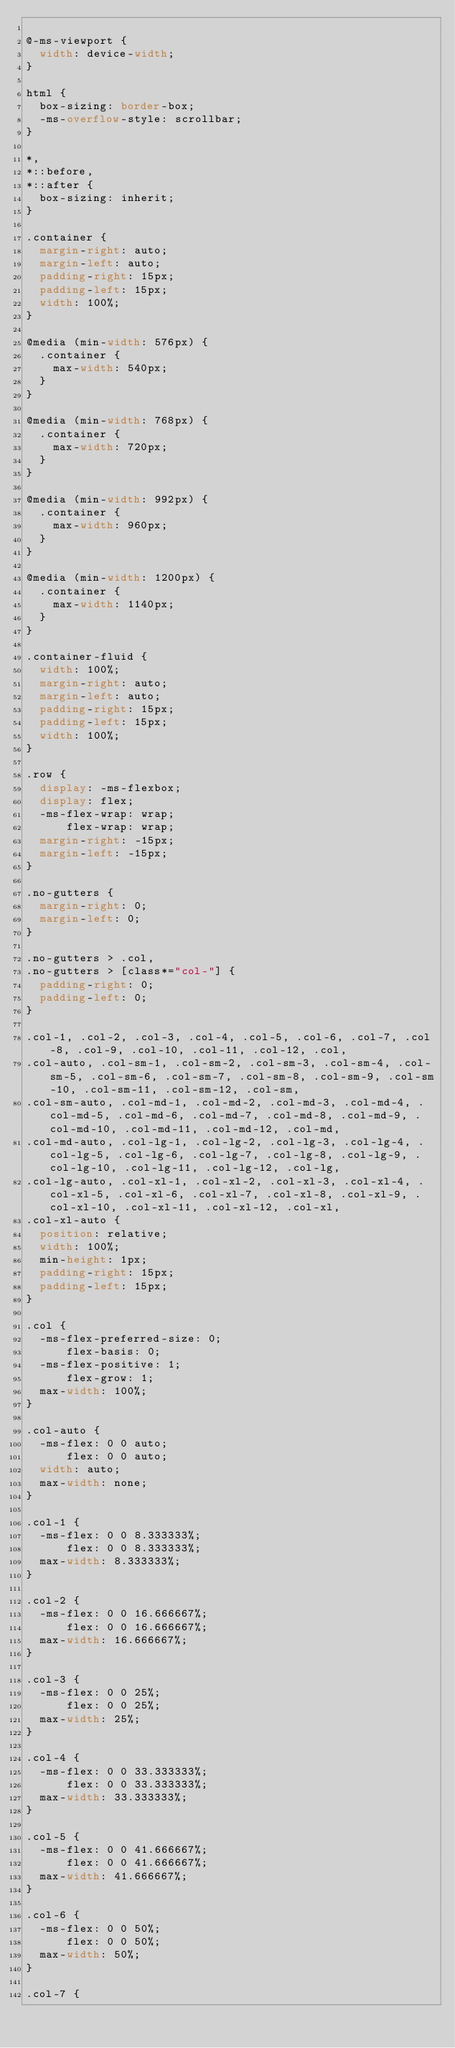<code> <loc_0><loc_0><loc_500><loc_500><_CSS_>
@-ms-viewport {
  width: device-width;
}

html {
  box-sizing: border-box;
  -ms-overflow-style: scrollbar;
}

*,
*::before,
*::after {
  box-sizing: inherit;
}

.container {
  margin-right: auto;
  margin-left: auto;
  padding-right: 15px;
  padding-left: 15px;
  width: 100%;
}

@media (min-width: 576px) {
  .container {
    max-width: 540px;
  }
}

@media (min-width: 768px) {
  .container {
    max-width: 720px;
  }
}

@media (min-width: 992px) {
  .container {
    max-width: 960px;
  }
}

@media (min-width: 1200px) {
  .container {
    max-width: 1140px;
  }
}

.container-fluid {
  width: 100%;
  margin-right: auto;
  margin-left: auto;
  padding-right: 15px;
  padding-left: 15px;
  width: 100%;
}

.row {
  display: -ms-flexbox;
  display: flex;
  -ms-flex-wrap: wrap;
      flex-wrap: wrap;
  margin-right: -15px;
  margin-left: -15px;
}

.no-gutters {
  margin-right: 0;
  margin-left: 0;
}

.no-gutters > .col,
.no-gutters > [class*="col-"] {
  padding-right: 0;
  padding-left: 0;
}

.col-1, .col-2, .col-3, .col-4, .col-5, .col-6, .col-7, .col-8, .col-9, .col-10, .col-11, .col-12, .col,
.col-auto, .col-sm-1, .col-sm-2, .col-sm-3, .col-sm-4, .col-sm-5, .col-sm-6, .col-sm-7, .col-sm-8, .col-sm-9, .col-sm-10, .col-sm-11, .col-sm-12, .col-sm,
.col-sm-auto, .col-md-1, .col-md-2, .col-md-3, .col-md-4, .col-md-5, .col-md-6, .col-md-7, .col-md-8, .col-md-9, .col-md-10, .col-md-11, .col-md-12, .col-md,
.col-md-auto, .col-lg-1, .col-lg-2, .col-lg-3, .col-lg-4, .col-lg-5, .col-lg-6, .col-lg-7, .col-lg-8, .col-lg-9, .col-lg-10, .col-lg-11, .col-lg-12, .col-lg,
.col-lg-auto, .col-xl-1, .col-xl-2, .col-xl-3, .col-xl-4, .col-xl-5, .col-xl-6, .col-xl-7, .col-xl-8, .col-xl-9, .col-xl-10, .col-xl-11, .col-xl-12, .col-xl,
.col-xl-auto {
  position: relative;
  width: 100%;
  min-height: 1px;
  padding-right: 15px;
  padding-left: 15px;
}

.col {
  -ms-flex-preferred-size: 0;
      flex-basis: 0;
  -ms-flex-positive: 1;
      flex-grow: 1;
  max-width: 100%;
}

.col-auto {
  -ms-flex: 0 0 auto;
      flex: 0 0 auto;
  width: auto;
  max-width: none;
}

.col-1 {
  -ms-flex: 0 0 8.333333%;
      flex: 0 0 8.333333%;
  max-width: 8.333333%;
}

.col-2 {
  -ms-flex: 0 0 16.666667%;
      flex: 0 0 16.666667%;
  max-width: 16.666667%;
}

.col-3 {
  -ms-flex: 0 0 25%;
      flex: 0 0 25%;
  max-width: 25%;
}

.col-4 {
  -ms-flex: 0 0 33.333333%;
      flex: 0 0 33.333333%;
  max-width: 33.333333%;
}

.col-5 {
  -ms-flex: 0 0 41.666667%;
      flex: 0 0 41.666667%;
  max-width: 41.666667%;
}

.col-6 {
  -ms-flex: 0 0 50%;
      flex: 0 0 50%;
  max-width: 50%;
}

.col-7 {</code> 